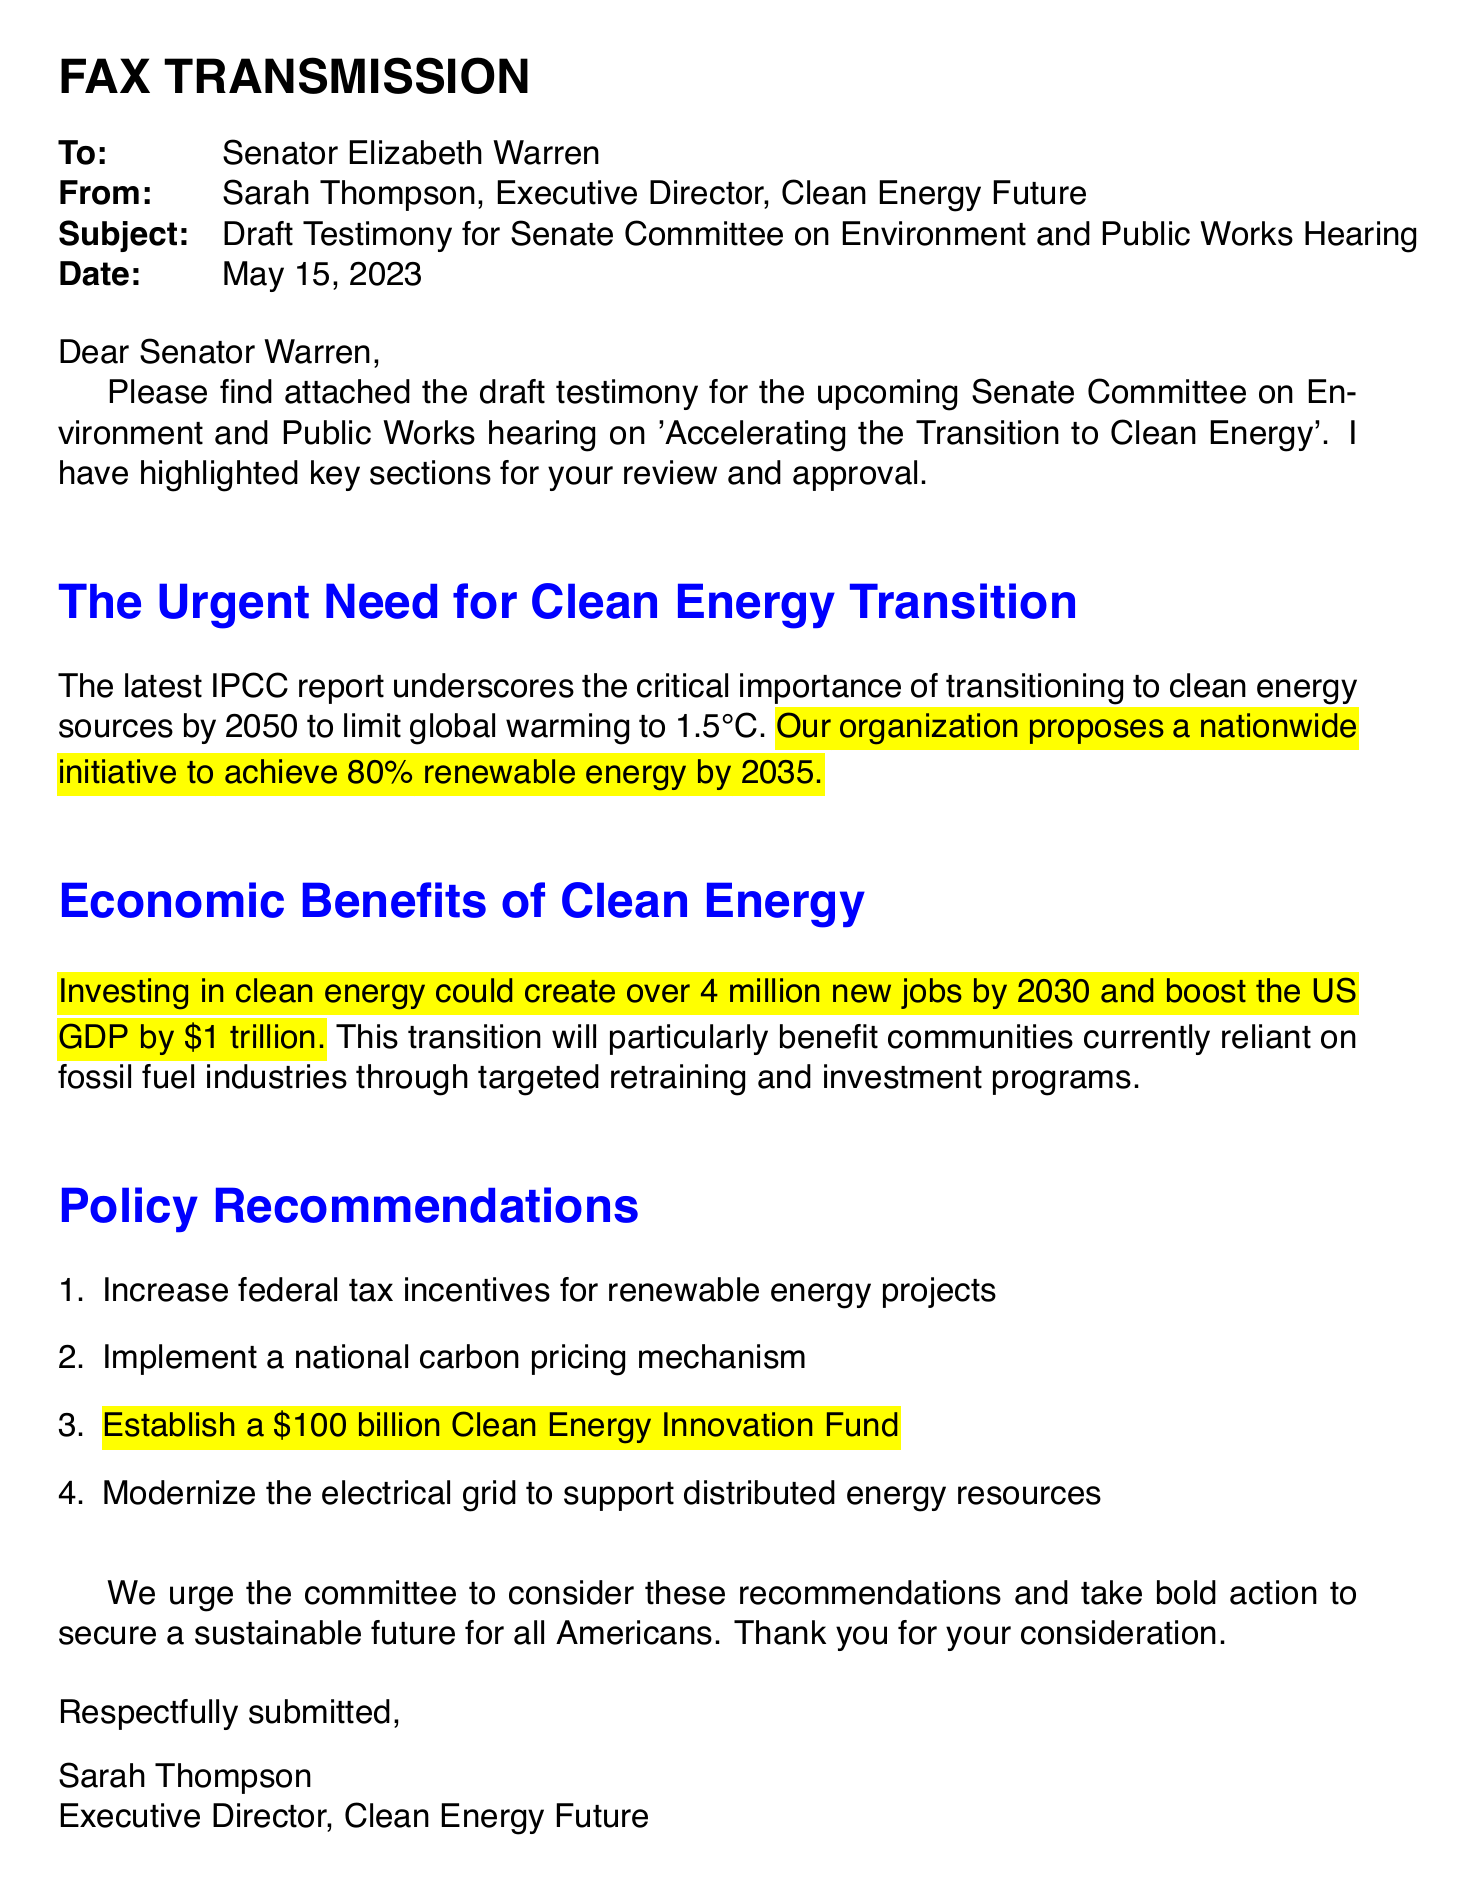What is the date of the fax? The date of the fax is specifically mentioned in the document as May 15, 2023.
Answer: May 15, 2023 Who is the sender of the fax? The sender is identified within the document as Sarah Thompson, Executive Director of Clean Energy Future.
Answer: Sarah Thompson What is the subject of the fax? The subject clearly outlined in the fax is 'Draft Testimony for Senate Committee on Environment and Public Works Hearing'.
Answer: Draft Testimony for Senate Committee on Environment and Public Works Hearing What is the proposed percentage of renewable energy by 2035? The document states that the organization proposes 80% renewable energy by 2035.
Answer: 80% How many new jobs could investing in clean energy create by 2030? The document indicates that investing in clean energy could create over 4 million new jobs by 2030.
Answer: 4 million What is the value of the Clean Energy Innovation Fund proposed? The highlighted section suggests establishing a Clean Energy Innovation Fund valued at $100 billion.
Answer: $100 billion What does the latest IPCC report emphasize? The document mentions that the IPCC report underscores the critical importance of transitioning to clean energy sources.
Answer: Transitioning to clean energy sources What action does the document urge the committee to take? The document urges the committee to consider policy recommendations and take bold action for a sustainable future.
Answer: Take bold action What type of document is this? The format and title suggest it is a fax transmission containing draft testimony.
Answer: Fax transmission 